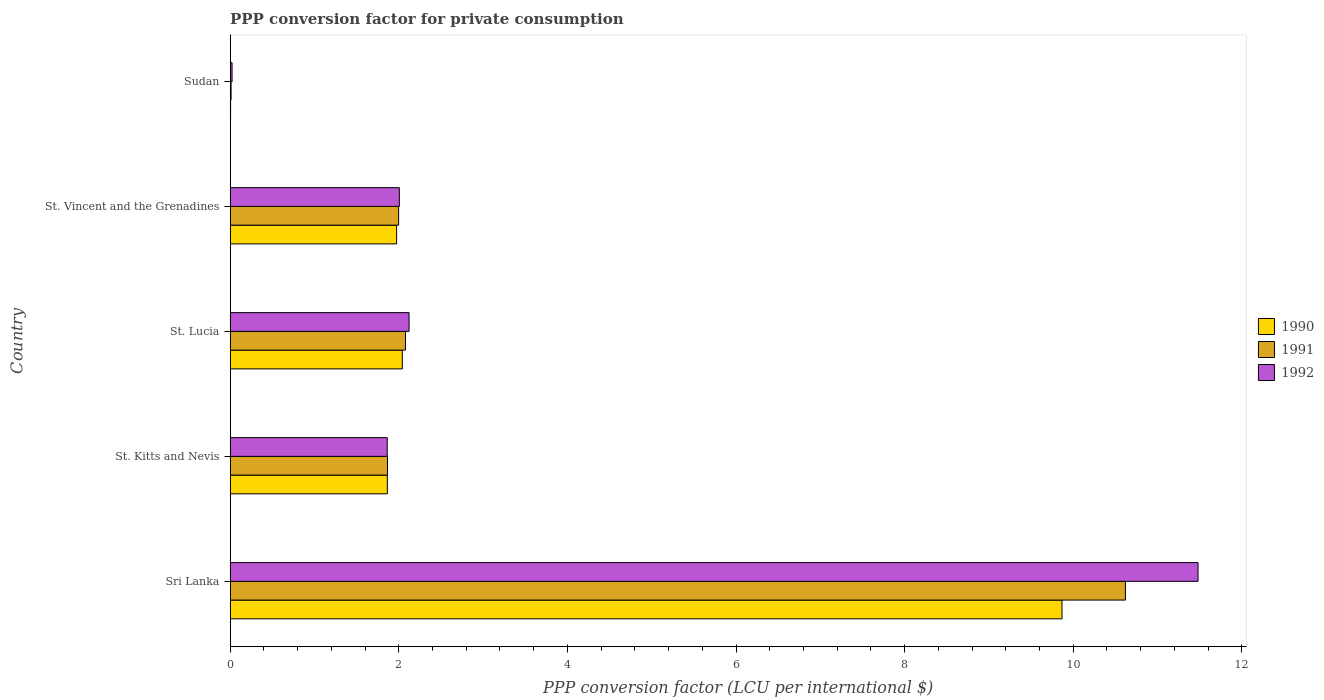How many different coloured bars are there?
Provide a succinct answer. 3. Are the number of bars per tick equal to the number of legend labels?
Your answer should be compact. Yes. How many bars are there on the 3rd tick from the top?
Provide a short and direct response. 3. How many bars are there on the 2nd tick from the bottom?
Provide a short and direct response. 3. What is the label of the 2nd group of bars from the top?
Provide a succinct answer. St. Vincent and the Grenadines. What is the PPP conversion factor for private consumption in 1992 in St. Kitts and Nevis?
Give a very brief answer. 1.86. Across all countries, what is the maximum PPP conversion factor for private consumption in 1990?
Your answer should be very brief. 9.87. Across all countries, what is the minimum PPP conversion factor for private consumption in 1990?
Ensure brevity in your answer.  0. In which country was the PPP conversion factor for private consumption in 1990 maximum?
Offer a terse response. Sri Lanka. In which country was the PPP conversion factor for private consumption in 1991 minimum?
Your answer should be very brief. Sudan. What is the total PPP conversion factor for private consumption in 1990 in the graph?
Your answer should be very brief. 15.75. What is the difference between the PPP conversion factor for private consumption in 1991 in St. Lucia and that in Sudan?
Provide a short and direct response. 2.07. What is the difference between the PPP conversion factor for private consumption in 1991 in Sudan and the PPP conversion factor for private consumption in 1990 in St. Kitts and Nevis?
Offer a terse response. -1.85. What is the average PPP conversion factor for private consumption in 1990 per country?
Offer a very short reply. 3.15. What is the difference between the PPP conversion factor for private consumption in 1992 and PPP conversion factor for private consumption in 1990 in Sudan?
Make the answer very short. 0.02. In how many countries, is the PPP conversion factor for private consumption in 1991 greater than 9.6 LCU?
Ensure brevity in your answer.  1. What is the ratio of the PPP conversion factor for private consumption in 1990 in St. Kitts and Nevis to that in Sudan?
Keep it short and to the point. 380.39. Is the PPP conversion factor for private consumption in 1992 in St. Vincent and the Grenadines less than that in Sudan?
Give a very brief answer. No. Is the difference between the PPP conversion factor for private consumption in 1992 in Sri Lanka and St. Vincent and the Grenadines greater than the difference between the PPP conversion factor for private consumption in 1990 in Sri Lanka and St. Vincent and the Grenadines?
Make the answer very short. Yes. What is the difference between the highest and the second highest PPP conversion factor for private consumption in 1990?
Ensure brevity in your answer.  7.83. What is the difference between the highest and the lowest PPP conversion factor for private consumption in 1990?
Give a very brief answer. 9.86. In how many countries, is the PPP conversion factor for private consumption in 1990 greater than the average PPP conversion factor for private consumption in 1990 taken over all countries?
Your response must be concise. 1. What does the 3rd bar from the top in St. Lucia represents?
Make the answer very short. 1990. How many bars are there?
Keep it short and to the point. 15. Does the graph contain any zero values?
Your answer should be very brief. No. What is the title of the graph?
Offer a terse response. PPP conversion factor for private consumption. Does "1981" appear as one of the legend labels in the graph?
Offer a very short reply. No. What is the label or title of the X-axis?
Provide a short and direct response. PPP conversion factor (LCU per international $). What is the PPP conversion factor (LCU per international $) of 1990 in Sri Lanka?
Keep it short and to the point. 9.87. What is the PPP conversion factor (LCU per international $) in 1991 in Sri Lanka?
Offer a very short reply. 10.62. What is the PPP conversion factor (LCU per international $) of 1992 in Sri Lanka?
Your response must be concise. 11.48. What is the PPP conversion factor (LCU per international $) in 1990 in St. Kitts and Nevis?
Your response must be concise. 1.86. What is the PPP conversion factor (LCU per international $) of 1991 in St. Kitts and Nevis?
Your answer should be very brief. 1.87. What is the PPP conversion factor (LCU per international $) of 1992 in St. Kitts and Nevis?
Keep it short and to the point. 1.86. What is the PPP conversion factor (LCU per international $) in 1990 in St. Lucia?
Offer a very short reply. 2.04. What is the PPP conversion factor (LCU per international $) of 1991 in St. Lucia?
Keep it short and to the point. 2.08. What is the PPP conversion factor (LCU per international $) in 1992 in St. Lucia?
Make the answer very short. 2.12. What is the PPP conversion factor (LCU per international $) in 1990 in St. Vincent and the Grenadines?
Your answer should be compact. 1.97. What is the PPP conversion factor (LCU per international $) in 1991 in St. Vincent and the Grenadines?
Your answer should be compact. 2. What is the PPP conversion factor (LCU per international $) of 1992 in St. Vincent and the Grenadines?
Provide a short and direct response. 2.01. What is the PPP conversion factor (LCU per international $) in 1990 in Sudan?
Give a very brief answer. 0. What is the PPP conversion factor (LCU per international $) in 1991 in Sudan?
Offer a terse response. 0.01. What is the PPP conversion factor (LCU per international $) of 1992 in Sudan?
Your answer should be compact. 0.02. Across all countries, what is the maximum PPP conversion factor (LCU per international $) of 1990?
Provide a succinct answer. 9.87. Across all countries, what is the maximum PPP conversion factor (LCU per international $) of 1991?
Your answer should be compact. 10.62. Across all countries, what is the maximum PPP conversion factor (LCU per international $) of 1992?
Your answer should be very brief. 11.48. Across all countries, what is the minimum PPP conversion factor (LCU per international $) in 1990?
Provide a succinct answer. 0. Across all countries, what is the minimum PPP conversion factor (LCU per international $) of 1991?
Give a very brief answer. 0.01. Across all countries, what is the minimum PPP conversion factor (LCU per international $) in 1992?
Your answer should be very brief. 0.02. What is the total PPP conversion factor (LCU per international $) in 1990 in the graph?
Your answer should be very brief. 15.75. What is the total PPP conversion factor (LCU per international $) in 1991 in the graph?
Your response must be concise. 16.57. What is the total PPP conversion factor (LCU per international $) of 1992 in the graph?
Your response must be concise. 17.49. What is the difference between the PPP conversion factor (LCU per international $) in 1990 in Sri Lanka and that in St. Kitts and Nevis?
Ensure brevity in your answer.  8. What is the difference between the PPP conversion factor (LCU per international $) of 1991 in Sri Lanka and that in St. Kitts and Nevis?
Ensure brevity in your answer.  8.75. What is the difference between the PPP conversion factor (LCU per international $) in 1992 in Sri Lanka and that in St. Kitts and Nevis?
Offer a very short reply. 9.62. What is the difference between the PPP conversion factor (LCU per international $) in 1990 in Sri Lanka and that in St. Lucia?
Provide a short and direct response. 7.83. What is the difference between the PPP conversion factor (LCU per international $) of 1991 in Sri Lanka and that in St. Lucia?
Offer a terse response. 8.54. What is the difference between the PPP conversion factor (LCU per international $) of 1992 in Sri Lanka and that in St. Lucia?
Your answer should be very brief. 9.36. What is the difference between the PPP conversion factor (LCU per international $) of 1990 in Sri Lanka and that in St. Vincent and the Grenadines?
Your answer should be compact. 7.89. What is the difference between the PPP conversion factor (LCU per international $) of 1991 in Sri Lanka and that in St. Vincent and the Grenadines?
Your response must be concise. 8.62. What is the difference between the PPP conversion factor (LCU per international $) of 1992 in Sri Lanka and that in St. Vincent and the Grenadines?
Give a very brief answer. 9.47. What is the difference between the PPP conversion factor (LCU per international $) in 1990 in Sri Lanka and that in Sudan?
Make the answer very short. 9.86. What is the difference between the PPP conversion factor (LCU per international $) in 1991 in Sri Lanka and that in Sudan?
Your answer should be very brief. 10.61. What is the difference between the PPP conversion factor (LCU per international $) of 1992 in Sri Lanka and that in Sudan?
Make the answer very short. 11.46. What is the difference between the PPP conversion factor (LCU per international $) of 1990 in St. Kitts and Nevis and that in St. Lucia?
Give a very brief answer. -0.18. What is the difference between the PPP conversion factor (LCU per international $) of 1991 in St. Kitts and Nevis and that in St. Lucia?
Make the answer very short. -0.21. What is the difference between the PPP conversion factor (LCU per international $) in 1992 in St. Kitts and Nevis and that in St. Lucia?
Offer a very short reply. -0.26. What is the difference between the PPP conversion factor (LCU per international $) of 1990 in St. Kitts and Nevis and that in St. Vincent and the Grenadines?
Offer a terse response. -0.11. What is the difference between the PPP conversion factor (LCU per international $) of 1991 in St. Kitts and Nevis and that in St. Vincent and the Grenadines?
Provide a succinct answer. -0.13. What is the difference between the PPP conversion factor (LCU per international $) in 1992 in St. Kitts and Nevis and that in St. Vincent and the Grenadines?
Make the answer very short. -0.14. What is the difference between the PPP conversion factor (LCU per international $) in 1990 in St. Kitts and Nevis and that in Sudan?
Your answer should be compact. 1.86. What is the difference between the PPP conversion factor (LCU per international $) in 1991 in St. Kitts and Nevis and that in Sudan?
Provide a succinct answer. 1.86. What is the difference between the PPP conversion factor (LCU per international $) of 1992 in St. Kitts and Nevis and that in Sudan?
Offer a very short reply. 1.84. What is the difference between the PPP conversion factor (LCU per international $) in 1990 in St. Lucia and that in St. Vincent and the Grenadines?
Give a very brief answer. 0.07. What is the difference between the PPP conversion factor (LCU per international $) of 1991 in St. Lucia and that in St. Vincent and the Grenadines?
Your response must be concise. 0.08. What is the difference between the PPP conversion factor (LCU per international $) of 1992 in St. Lucia and that in St. Vincent and the Grenadines?
Offer a terse response. 0.12. What is the difference between the PPP conversion factor (LCU per international $) in 1990 in St. Lucia and that in Sudan?
Make the answer very short. 2.04. What is the difference between the PPP conversion factor (LCU per international $) of 1991 in St. Lucia and that in Sudan?
Offer a very short reply. 2.07. What is the difference between the PPP conversion factor (LCU per international $) of 1992 in St. Lucia and that in Sudan?
Offer a terse response. 2.1. What is the difference between the PPP conversion factor (LCU per international $) in 1990 in St. Vincent and the Grenadines and that in Sudan?
Keep it short and to the point. 1.97. What is the difference between the PPP conversion factor (LCU per international $) of 1991 in St. Vincent and the Grenadines and that in Sudan?
Ensure brevity in your answer.  1.99. What is the difference between the PPP conversion factor (LCU per international $) of 1992 in St. Vincent and the Grenadines and that in Sudan?
Provide a short and direct response. 1.98. What is the difference between the PPP conversion factor (LCU per international $) of 1990 in Sri Lanka and the PPP conversion factor (LCU per international $) of 1991 in St. Kitts and Nevis?
Offer a very short reply. 8. What is the difference between the PPP conversion factor (LCU per international $) of 1990 in Sri Lanka and the PPP conversion factor (LCU per international $) of 1992 in St. Kitts and Nevis?
Keep it short and to the point. 8. What is the difference between the PPP conversion factor (LCU per international $) of 1991 in Sri Lanka and the PPP conversion factor (LCU per international $) of 1992 in St. Kitts and Nevis?
Your answer should be very brief. 8.76. What is the difference between the PPP conversion factor (LCU per international $) in 1990 in Sri Lanka and the PPP conversion factor (LCU per international $) in 1991 in St. Lucia?
Provide a succinct answer. 7.79. What is the difference between the PPP conversion factor (LCU per international $) in 1990 in Sri Lanka and the PPP conversion factor (LCU per international $) in 1992 in St. Lucia?
Ensure brevity in your answer.  7.75. What is the difference between the PPP conversion factor (LCU per international $) of 1991 in Sri Lanka and the PPP conversion factor (LCU per international $) of 1992 in St. Lucia?
Offer a very short reply. 8.5. What is the difference between the PPP conversion factor (LCU per international $) in 1990 in Sri Lanka and the PPP conversion factor (LCU per international $) in 1991 in St. Vincent and the Grenadines?
Offer a terse response. 7.87. What is the difference between the PPP conversion factor (LCU per international $) of 1990 in Sri Lanka and the PPP conversion factor (LCU per international $) of 1992 in St. Vincent and the Grenadines?
Give a very brief answer. 7.86. What is the difference between the PPP conversion factor (LCU per international $) in 1991 in Sri Lanka and the PPP conversion factor (LCU per international $) in 1992 in St. Vincent and the Grenadines?
Offer a terse response. 8.61. What is the difference between the PPP conversion factor (LCU per international $) of 1990 in Sri Lanka and the PPP conversion factor (LCU per international $) of 1991 in Sudan?
Offer a terse response. 9.86. What is the difference between the PPP conversion factor (LCU per international $) in 1990 in Sri Lanka and the PPP conversion factor (LCU per international $) in 1992 in Sudan?
Provide a succinct answer. 9.84. What is the difference between the PPP conversion factor (LCU per international $) of 1991 in Sri Lanka and the PPP conversion factor (LCU per international $) of 1992 in Sudan?
Your answer should be compact. 10.6. What is the difference between the PPP conversion factor (LCU per international $) in 1990 in St. Kitts and Nevis and the PPP conversion factor (LCU per international $) in 1991 in St. Lucia?
Provide a succinct answer. -0.21. What is the difference between the PPP conversion factor (LCU per international $) in 1990 in St. Kitts and Nevis and the PPP conversion factor (LCU per international $) in 1992 in St. Lucia?
Make the answer very short. -0.26. What is the difference between the PPP conversion factor (LCU per international $) of 1991 in St. Kitts and Nevis and the PPP conversion factor (LCU per international $) of 1992 in St. Lucia?
Keep it short and to the point. -0.26. What is the difference between the PPP conversion factor (LCU per international $) in 1990 in St. Kitts and Nevis and the PPP conversion factor (LCU per international $) in 1991 in St. Vincent and the Grenadines?
Offer a very short reply. -0.13. What is the difference between the PPP conversion factor (LCU per international $) of 1990 in St. Kitts and Nevis and the PPP conversion factor (LCU per international $) of 1992 in St. Vincent and the Grenadines?
Your answer should be compact. -0.14. What is the difference between the PPP conversion factor (LCU per international $) in 1991 in St. Kitts and Nevis and the PPP conversion factor (LCU per international $) in 1992 in St. Vincent and the Grenadines?
Your answer should be very brief. -0.14. What is the difference between the PPP conversion factor (LCU per international $) in 1990 in St. Kitts and Nevis and the PPP conversion factor (LCU per international $) in 1991 in Sudan?
Offer a very short reply. 1.85. What is the difference between the PPP conversion factor (LCU per international $) in 1990 in St. Kitts and Nevis and the PPP conversion factor (LCU per international $) in 1992 in Sudan?
Give a very brief answer. 1.84. What is the difference between the PPP conversion factor (LCU per international $) in 1991 in St. Kitts and Nevis and the PPP conversion factor (LCU per international $) in 1992 in Sudan?
Provide a succinct answer. 1.84. What is the difference between the PPP conversion factor (LCU per international $) in 1990 in St. Lucia and the PPP conversion factor (LCU per international $) in 1991 in St. Vincent and the Grenadines?
Your response must be concise. 0.04. What is the difference between the PPP conversion factor (LCU per international $) of 1990 in St. Lucia and the PPP conversion factor (LCU per international $) of 1992 in St. Vincent and the Grenadines?
Your answer should be compact. 0.04. What is the difference between the PPP conversion factor (LCU per international $) in 1991 in St. Lucia and the PPP conversion factor (LCU per international $) in 1992 in St. Vincent and the Grenadines?
Your response must be concise. 0.07. What is the difference between the PPP conversion factor (LCU per international $) in 1990 in St. Lucia and the PPP conversion factor (LCU per international $) in 1991 in Sudan?
Provide a succinct answer. 2.03. What is the difference between the PPP conversion factor (LCU per international $) of 1990 in St. Lucia and the PPP conversion factor (LCU per international $) of 1992 in Sudan?
Offer a terse response. 2.02. What is the difference between the PPP conversion factor (LCU per international $) of 1991 in St. Lucia and the PPP conversion factor (LCU per international $) of 1992 in Sudan?
Keep it short and to the point. 2.06. What is the difference between the PPP conversion factor (LCU per international $) of 1990 in St. Vincent and the Grenadines and the PPP conversion factor (LCU per international $) of 1991 in Sudan?
Give a very brief answer. 1.96. What is the difference between the PPP conversion factor (LCU per international $) in 1990 in St. Vincent and the Grenadines and the PPP conversion factor (LCU per international $) in 1992 in Sudan?
Keep it short and to the point. 1.95. What is the difference between the PPP conversion factor (LCU per international $) in 1991 in St. Vincent and the Grenadines and the PPP conversion factor (LCU per international $) in 1992 in Sudan?
Offer a terse response. 1.98. What is the average PPP conversion factor (LCU per international $) of 1990 per country?
Ensure brevity in your answer.  3.15. What is the average PPP conversion factor (LCU per international $) of 1991 per country?
Offer a terse response. 3.31. What is the average PPP conversion factor (LCU per international $) in 1992 per country?
Ensure brevity in your answer.  3.5. What is the difference between the PPP conversion factor (LCU per international $) of 1990 and PPP conversion factor (LCU per international $) of 1991 in Sri Lanka?
Your answer should be compact. -0.75. What is the difference between the PPP conversion factor (LCU per international $) in 1990 and PPP conversion factor (LCU per international $) in 1992 in Sri Lanka?
Provide a short and direct response. -1.61. What is the difference between the PPP conversion factor (LCU per international $) in 1991 and PPP conversion factor (LCU per international $) in 1992 in Sri Lanka?
Offer a terse response. -0.86. What is the difference between the PPP conversion factor (LCU per international $) of 1990 and PPP conversion factor (LCU per international $) of 1991 in St. Kitts and Nevis?
Give a very brief answer. -0. What is the difference between the PPP conversion factor (LCU per international $) of 1990 and PPP conversion factor (LCU per international $) of 1992 in St. Kitts and Nevis?
Provide a succinct answer. 0. What is the difference between the PPP conversion factor (LCU per international $) in 1991 and PPP conversion factor (LCU per international $) in 1992 in St. Kitts and Nevis?
Give a very brief answer. 0. What is the difference between the PPP conversion factor (LCU per international $) in 1990 and PPP conversion factor (LCU per international $) in 1991 in St. Lucia?
Keep it short and to the point. -0.04. What is the difference between the PPP conversion factor (LCU per international $) in 1990 and PPP conversion factor (LCU per international $) in 1992 in St. Lucia?
Keep it short and to the point. -0.08. What is the difference between the PPP conversion factor (LCU per international $) in 1991 and PPP conversion factor (LCU per international $) in 1992 in St. Lucia?
Make the answer very short. -0.04. What is the difference between the PPP conversion factor (LCU per international $) of 1990 and PPP conversion factor (LCU per international $) of 1991 in St. Vincent and the Grenadines?
Your response must be concise. -0.02. What is the difference between the PPP conversion factor (LCU per international $) of 1990 and PPP conversion factor (LCU per international $) of 1992 in St. Vincent and the Grenadines?
Your response must be concise. -0.03. What is the difference between the PPP conversion factor (LCU per international $) in 1991 and PPP conversion factor (LCU per international $) in 1992 in St. Vincent and the Grenadines?
Ensure brevity in your answer.  -0.01. What is the difference between the PPP conversion factor (LCU per international $) of 1990 and PPP conversion factor (LCU per international $) of 1991 in Sudan?
Your answer should be compact. -0.01. What is the difference between the PPP conversion factor (LCU per international $) in 1990 and PPP conversion factor (LCU per international $) in 1992 in Sudan?
Your response must be concise. -0.02. What is the difference between the PPP conversion factor (LCU per international $) in 1991 and PPP conversion factor (LCU per international $) in 1992 in Sudan?
Provide a succinct answer. -0.01. What is the ratio of the PPP conversion factor (LCU per international $) of 1990 in Sri Lanka to that in St. Kitts and Nevis?
Your response must be concise. 5.29. What is the ratio of the PPP conversion factor (LCU per international $) of 1991 in Sri Lanka to that in St. Kitts and Nevis?
Make the answer very short. 5.69. What is the ratio of the PPP conversion factor (LCU per international $) in 1992 in Sri Lanka to that in St. Kitts and Nevis?
Your answer should be compact. 6.16. What is the ratio of the PPP conversion factor (LCU per international $) of 1990 in Sri Lanka to that in St. Lucia?
Give a very brief answer. 4.83. What is the ratio of the PPP conversion factor (LCU per international $) of 1991 in Sri Lanka to that in St. Lucia?
Ensure brevity in your answer.  5.11. What is the ratio of the PPP conversion factor (LCU per international $) of 1992 in Sri Lanka to that in St. Lucia?
Your answer should be very brief. 5.41. What is the ratio of the PPP conversion factor (LCU per international $) of 1990 in Sri Lanka to that in St. Vincent and the Grenadines?
Keep it short and to the point. 5. What is the ratio of the PPP conversion factor (LCU per international $) in 1991 in Sri Lanka to that in St. Vincent and the Grenadines?
Make the answer very short. 5.31. What is the ratio of the PPP conversion factor (LCU per international $) of 1992 in Sri Lanka to that in St. Vincent and the Grenadines?
Your answer should be compact. 5.72. What is the ratio of the PPP conversion factor (LCU per international $) of 1990 in Sri Lanka to that in Sudan?
Keep it short and to the point. 2013.1. What is the ratio of the PPP conversion factor (LCU per international $) in 1991 in Sri Lanka to that in Sudan?
Offer a very short reply. 1010.12. What is the ratio of the PPP conversion factor (LCU per international $) of 1992 in Sri Lanka to that in Sudan?
Make the answer very short. 516.99. What is the ratio of the PPP conversion factor (LCU per international $) in 1990 in St. Kitts and Nevis to that in St. Lucia?
Your answer should be compact. 0.91. What is the ratio of the PPP conversion factor (LCU per international $) of 1991 in St. Kitts and Nevis to that in St. Lucia?
Make the answer very short. 0.9. What is the ratio of the PPP conversion factor (LCU per international $) of 1992 in St. Kitts and Nevis to that in St. Lucia?
Offer a terse response. 0.88. What is the ratio of the PPP conversion factor (LCU per international $) in 1990 in St. Kitts and Nevis to that in St. Vincent and the Grenadines?
Make the answer very short. 0.94. What is the ratio of the PPP conversion factor (LCU per international $) of 1991 in St. Kitts and Nevis to that in St. Vincent and the Grenadines?
Your response must be concise. 0.93. What is the ratio of the PPP conversion factor (LCU per international $) of 1992 in St. Kitts and Nevis to that in St. Vincent and the Grenadines?
Offer a terse response. 0.93. What is the ratio of the PPP conversion factor (LCU per international $) in 1990 in St. Kitts and Nevis to that in Sudan?
Make the answer very short. 380.39. What is the ratio of the PPP conversion factor (LCU per international $) of 1991 in St. Kitts and Nevis to that in Sudan?
Your answer should be very brief. 177.49. What is the ratio of the PPP conversion factor (LCU per international $) of 1992 in St. Kitts and Nevis to that in Sudan?
Provide a short and direct response. 83.89. What is the ratio of the PPP conversion factor (LCU per international $) in 1990 in St. Lucia to that in St. Vincent and the Grenadines?
Offer a very short reply. 1.03. What is the ratio of the PPP conversion factor (LCU per international $) in 1991 in St. Lucia to that in St. Vincent and the Grenadines?
Give a very brief answer. 1.04. What is the ratio of the PPP conversion factor (LCU per international $) of 1992 in St. Lucia to that in St. Vincent and the Grenadines?
Your answer should be compact. 1.06. What is the ratio of the PPP conversion factor (LCU per international $) of 1990 in St. Lucia to that in Sudan?
Provide a succinct answer. 416.59. What is the ratio of the PPP conversion factor (LCU per international $) of 1991 in St. Lucia to that in Sudan?
Your response must be concise. 197.79. What is the ratio of the PPP conversion factor (LCU per international $) in 1992 in St. Lucia to that in Sudan?
Provide a short and direct response. 95.55. What is the ratio of the PPP conversion factor (LCU per international $) in 1990 in St. Vincent and the Grenadines to that in Sudan?
Provide a short and direct response. 402.81. What is the ratio of the PPP conversion factor (LCU per international $) of 1991 in St. Vincent and the Grenadines to that in Sudan?
Provide a succinct answer. 190.06. What is the ratio of the PPP conversion factor (LCU per international $) in 1992 in St. Vincent and the Grenadines to that in Sudan?
Your answer should be very brief. 90.36. What is the difference between the highest and the second highest PPP conversion factor (LCU per international $) of 1990?
Ensure brevity in your answer.  7.83. What is the difference between the highest and the second highest PPP conversion factor (LCU per international $) of 1991?
Give a very brief answer. 8.54. What is the difference between the highest and the second highest PPP conversion factor (LCU per international $) in 1992?
Your answer should be compact. 9.36. What is the difference between the highest and the lowest PPP conversion factor (LCU per international $) of 1990?
Your answer should be compact. 9.86. What is the difference between the highest and the lowest PPP conversion factor (LCU per international $) of 1991?
Make the answer very short. 10.61. What is the difference between the highest and the lowest PPP conversion factor (LCU per international $) in 1992?
Give a very brief answer. 11.46. 